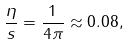<formula> <loc_0><loc_0><loc_500><loc_500>\frac { \eta } { s } = \frac { 1 } { 4 \pi } \approx 0 . 0 8 ,</formula> 